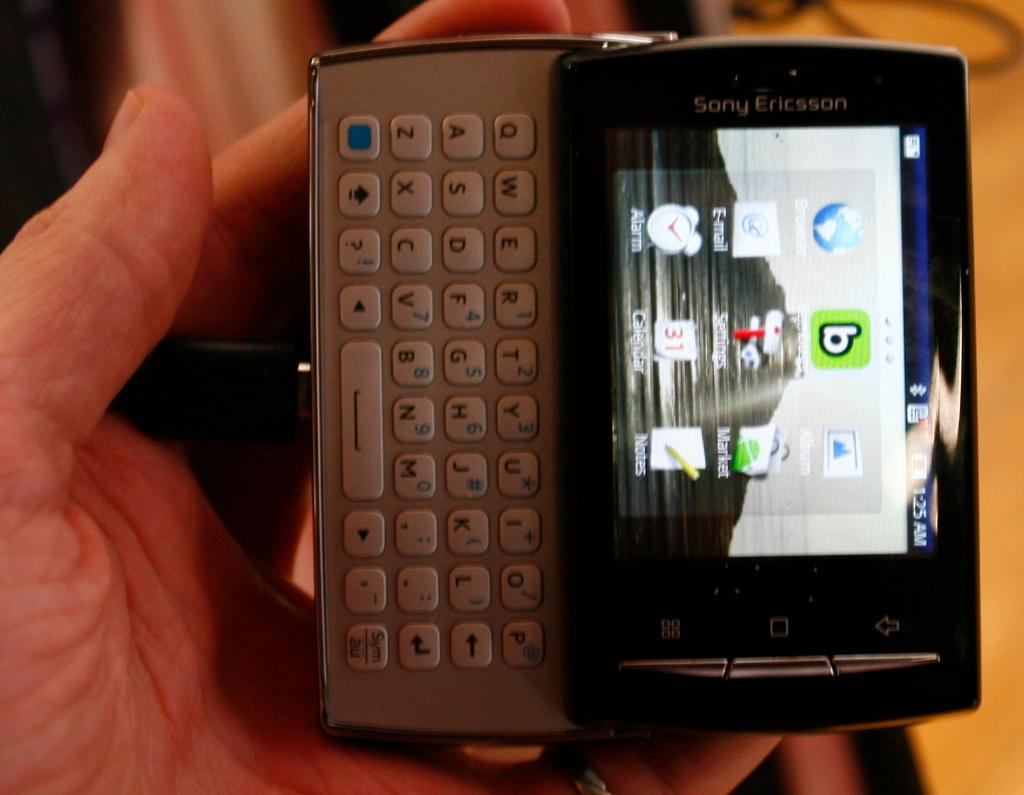Provide a one-sentence caption for the provided image. Sony Ericsson phone with keyboard is in a white person hand. 